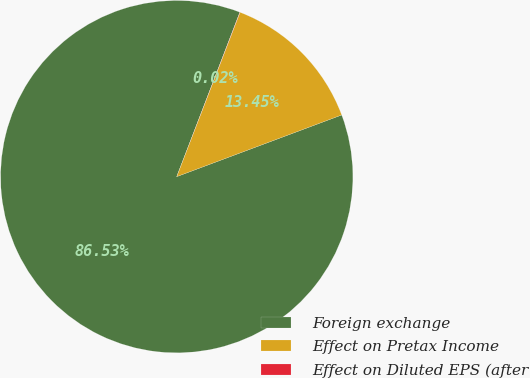Convert chart. <chart><loc_0><loc_0><loc_500><loc_500><pie_chart><fcel>Foreign exchange<fcel>Effect on Pretax Income<fcel>Effect on Diluted EPS (after<nl><fcel>86.53%<fcel>13.45%<fcel>0.02%<nl></chart> 